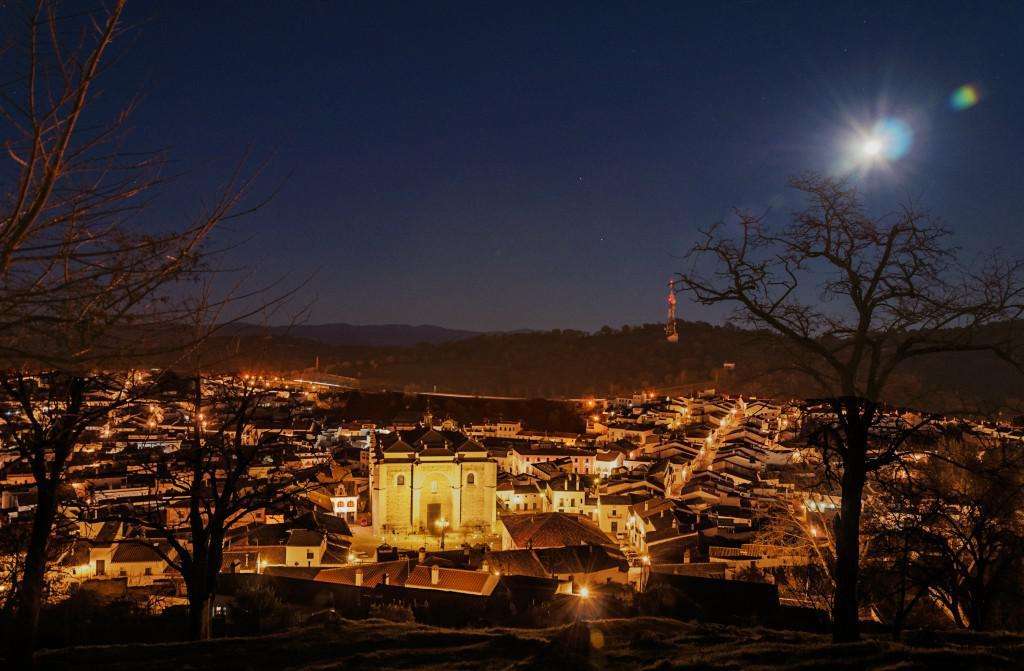What type of vegetation can be seen in the image? There are trees in the image. What structures are located behind the trees? There are buildings behind the trees. What are the poles with lights used for in the image? The poles with lights are likely used for illumination. What type of geographical feature can be seen in the image? There are hills visible in the image. What part of the natural environment is visible in the image? The sky is visible in the image. How does the map help navigate the area in the image? There is no map present in the image; it features trees, buildings, poles with lights, hills, and the sky. What type of alarm is triggered by the presence of the trees in the image? There is no alarm present in the image; it features trees, buildings, poles with lights, hills, and the sky. 